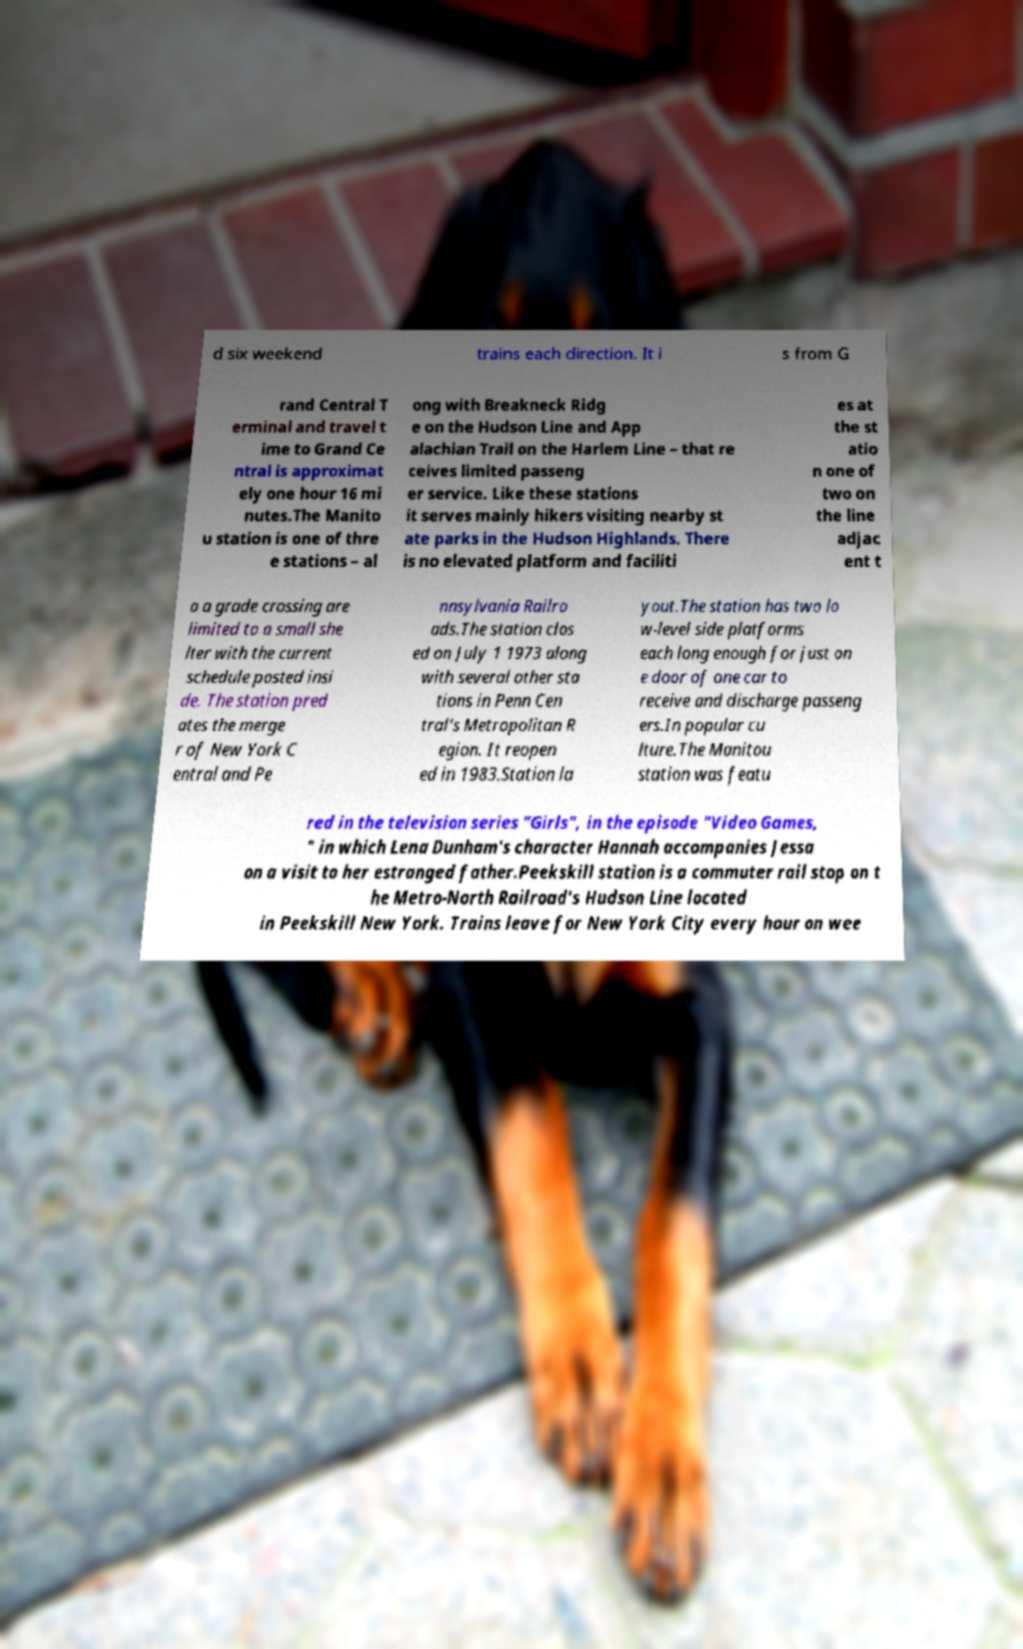There's text embedded in this image that I need extracted. Can you transcribe it verbatim? d six weekend trains each direction. It i s from G rand Central T erminal and travel t ime to Grand Ce ntral is approximat ely one hour 16 mi nutes.The Manito u station is one of thre e stations – al ong with Breakneck Ridg e on the Hudson Line and App alachian Trail on the Harlem Line – that re ceives limited passeng er service. Like these stations it serves mainly hikers visiting nearby st ate parks in the Hudson Highlands. There is no elevated platform and faciliti es at the st atio n one of two on the line adjac ent t o a grade crossing are limited to a small she lter with the current schedule posted insi de. The station pred ates the merge r of New York C entral and Pe nnsylvania Railro ads.The station clos ed on July 1 1973 along with several other sta tions in Penn Cen tral's Metropolitan R egion. It reopen ed in 1983.Station la yout.The station has two lo w-level side platforms each long enough for just on e door of one car to receive and discharge passeng ers.In popular cu lture.The Manitou station was featu red in the television series "Girls", in the episode "Video Games, " in which Lena Dunham's character Hannah accompanies Jessa on a visit to her estranged father.Peekskill station is a commuter rail stop on t he Metro-North Railroad's Hudson Line located in Peekskill New York. Trains leave for New York City every hour on wee 